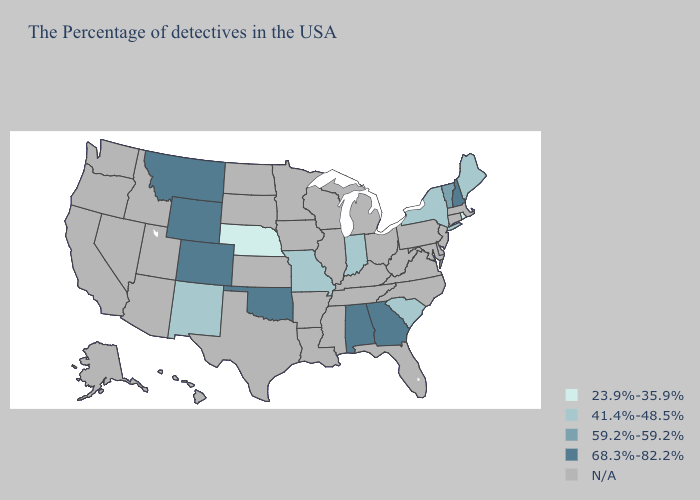Does Rhode Island have the highest value in the Northeast?
Write a very short answer. No. Does New Mexico have the highest value in the West?
Quick response, please. No. What is the highest value in the Northeast ?
Be succinct. 68.3%-82.2%. Name the states that have a value in the range 59.2%-59.2%?
Give a very brief answer. Vermont. Which states have the highest value in the USA?
Quick response, please. New Hampshire, Georgia, Alabama, Oklahoma, Wyoming, Colorado, Montana. Name the states that have a value in the range 68.3%-82.2%?
Quick response, please. New Hampshire, Georgia, Alabama, Oklahoma, Wyoming, Colorado, Montana. What is the value of Kentucky?
Be succinct. N/A. Does Montana have the highest value in the USA?
Answer briefly. Yes. Among the states that border Florida , which have the lowest value?
Concise answer only. Georgia, Alabama. What is the lowest value in states that border Idaho?
Short answer required. 68.3%-82.2%. Is the legend a continuous bar?
Answer briefly. No. What is the highest value in the South ?
Answer briefly. 68.3%-82.2%. What is the highest value in the Northeast ?
Give a very brief answer. 68.3%-82.2%. 